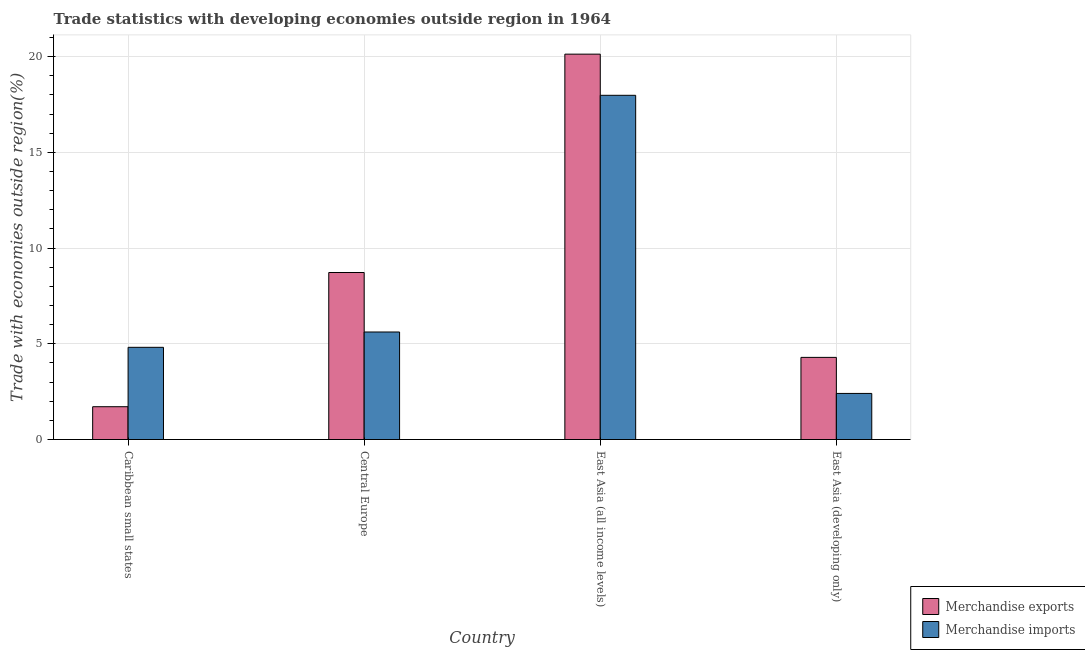How many different coloured bars are there?
Offer a very short reply. 2. How many groups of bars are there?
Your answer should be compact. 4. Are the number of bars per tick equal to the number of legend labels?
Ensure brevity in your answer.  Yes. Are the number of bars on each tick of the X-axis equal?
Provide a short and direct response. Yes. How many bars are there on the 4th tick from the right?
Make the answer very short. 2. What is the label of the 2nd group of bars from the left?
Give a very brief answer. Central Europe. In how many cases, is the number of bars for a given country not equal to the number of legend labels?
Your answer should be very brief. 0. What is the merchandise imports in East Asia (developing only)?
Offer a very short reply. 2.41. Across all countries, what is the maximum merchandise imports?
Your answer should be very brief. 17.98. Across all countries, what is the minimum merchandise imports?
Offer a terse response. 2.41. In which country was the merchandise imports maximum?
Your answer should be very brief. East Asia (all income levels). In which country was the merchandise exports minimum?
Provide a short and direct response. Caribbean small states. What is the total merchandise exports in the graph?
Give a very brief answer. 34.86. What is the difference between the merchandise imports in Caribbean small states and that in East Asia (all income levels)?
Give a very brief answer. -13.17. What is the difference between the merchandise exports in East Asia (developing only) and the merchandise imports in East Asia (all income levels)?
Give a very brief answer. -13.69. What is the average merchandise imports per country?
Give a very brief answer. 7.71. What is the difference between the merchandise imports and merchandise exports in East Asia (all income levels)?
Ensure brevity in your answer.  -2.15. What is the ratio of the merchandise exports in Caribbean small states to that in East Asia (all income levels)?
Your answer should be very brief. 0.09. Is the merchandise exports in Caribbean small states less than that in Central Europe?
Make the answer very short. Yes. What is the difference between the highest and the second highest merchandise imports?
Your response must be concise. 12.37. What is the difference between the highest and the lowest merchandise exports?
Ensure brevity in your answer.  18.42. How many bars are there?
Your answer should be very brief. 8. Are all the bars in the graph horizontal?
Make the answer very short. No. How many countries are there in the graph?
Provide a succinct answer. 4. Are the values on the major ticks of Y-axis written in scientific E-notation?
Make the answer very short. No. How many legend labels are there?
Keep it short and to the point. 2. What is the title of the graph?
Your response must be concise. Trade statistics with developing economies outside region in 1964. What is the label or title of the Y-axis?
Make the answer very short. Trade with economies outside region(%). What is the Trade with economies outside region(%) of Merchandise exports in Caribbean small states?
Your answer should be compact. 1.71. What is the Trade with economies outside region(%) in Merchandise imports in Caribbean small states?
Provide a short and direct response. 4.82. What is the Trade with economies outside region(%) of Merchandise exports in Central Europe?
Provide a short and direct response. 8.73. What is the Trade with economies outside region(%) of Merchandise imports in Central Europe?
Your answer should be very brief. 5.62. What is the Trade with economies outside region(%) in Merchandise exports in East Asia (all income levels)?
Your answer should be compact. 20.13. What is the Trade with economies outside region(%) in Merchandise imports in East Asia (all income levels)?
Your response must be concise. 17.98. What is the Trade with economies outside region(%) in Merchandise exports in East Asia (developing only)?
Provide a short and direct response. 4.29. What is the Trade with economies outside region(%) of Merchandise imports in East Asia (developing only)?
Your response must be concise. 2.41. Across all countries, what is the maximum Trade with economies outside region(%) in Merchandise exports?
Keep it short and to the point. 20.13. Across all countries, what is the maximum Trade with economies outside region(%) of Merchandise imports?
Provide a short and direct response. 17.98. Across all countries, what is the minimum Trade with economies outside region(%) in Merchandise exports?
Give a very brief answer. 1.71. Across all countries, what is the minimum Trade with economies outside region(%) in Merchandise imports?
Ensure brevity in your answer.  2.41. What is the total Trade with economies outside region(%) of Merchandise exports in the graph?
Your answer should be very brief. 34.86. What is the total Trade with economies outside region(%) in Merchandise imports in the graph?
Provide a succinct answer. 30.83. What is the difference between the Trade with economies outside region(%) of Merchandise exports in Caribbean small states and that in Central Europe?
Make the answer very short. -7.01. What is the difference between the Trade with economies outside region(%) in Merchandise imports in Caribbean small states and that in Central Europe?
Ensure brevity in your answer.  -0.8. What is the difference between the Trade with economies outside region(%) in Merchandise exports in Caribbean small states and that in East Asia (all income levels)?
Offer a very short reply. -18.42. What is the difference between the Trade with economies outside region(%) of Merchandise imports in Caribbean small states and that in East Asia (all income levels)?
Offer a terse response. -13.17. What is the difference between the Trade with economies outside region(%) of Merchandise exports in Caribbean small states and that in East Asia (developing only)?
Provide a succinct answer. -2.58. What is the difference between the Trade with economies outside region(%) of Merchandise imports in Caribbean small states and that in East Asia (developing only)?
Ensure brevity in your answer.  2.41. What is the difference between the Trade with economies outside region(%) in Merchandise exports in Central Europe and that in East Asia (all income levels)?
Make the answer very short. -11.41. What is the difference between the Trade with economies outside region(%) of Merchandise imports in Central Europe and that in East Asia (all income levels)?
Provide a short and direct response. -12.37. What is the difference between the Trade with economies outside region(%) of Merchandise exports in Central Europe and that in East Asia (developing only)?
Your response must be concise. 4.43. What is the difference between the Trade with economies outside region(%) in Merchandise imports in Central Europe and that in East Asia (developing only)?
Make the answer very short. 3.21. What is the difference between the Trade with economies outside region(%) of Merchandise exports in East Asia (all income levels) and that in East Asia (developing only)?
Ensure brevity in your answer.  15.84. What is the difference between the Trade with economies outside region(%) in Merchandise imports in East Asia (all income levels) and that in East Asia (developing only)?
Provide a succinct answer. 15.58. What is the difference between the Trade with economies outside region(%) in Merchandise exports in Caribbean small states and the Trade with economies outside region(%) in Merchandise imports in Central Europe?
Ensure brevity in your answer.  -3.9. What is the difference between the Trade with economies outside region(%) of Merchandise exports in Caribbean small states and the Trade with economies outside region(%) of Merchandise imports in East Asia (all income levels)?
Offer a terse response. -16.27. What is the difference between the Trade with economies outside region(%) in Merchandise exports in Caribbean small states and the Trade with economies outside region(%) in Merchandise imports in East Asia (developing only)?
Make the answer very short. -0.69. What is the difference between the Trade with economies outside region(%) of Merchandise exports in Central Europe and the Trade with economies outside region(%) of Merchandise imports in East Asia (all income levels)?
Offer a terse response. -9.26. What is the difference between the Trade with economies outside region(%) of Merchandise exports in Central Europe and the Trade with economies outside region(%) of Merchandise imports in East Asia (developing only)?
Provide a succinct answer. 6.32. What is the difference between the Trade with economies outside region(%) in Merchandise exports in East Asia (all income levels) and the Trade with economies outside region(%) in Merchandise imports in East Asia (developing only)?
Provide a short and direct response. 17.73. What is the average Trade with economies outside region(%) of Merchandise exports per country?
Provide a short and direct response. 8.72. What is the average Trade with economies outside region(%) of Merchandise imports per country?
Provide a succinct answer. 7.71. What is the difference between the Trade with economies outside region(%) in Merchandise exports and Trade with economies outside region(%) in Merchandise imports in Caribbean small states?
Keep it short and to the point. -3.1. What is the difference between the Trade with economies outside region(%) in Merchandise exports and Trade with economies outside region(%) in Merchandise imports in Central Europe?
Keep it short and to the point. 3.11. What is the difference between the Trade with economies outside region(%) of Merchandise exports and Trade with economies outside region(%) of Merchandise imports in East Asia (all income levels)?
Give a very brief answer. 2.15. What is the difference between the Trade with economies outside region(%) in Merchandise exports and Trade with economies outside region(%) in Merchandise imports in East Asia (developing only)?
Provide a short and direct response. 1.88. What is the ratio of the Trade with economies outside region(%) of Merchandise exports in Caribbean small states to that in Central Europe?
Your response must be concise. 0.2. What is the ratio of the Trade with economies outside region(%) of Merchandise imports in Caribbean small states to that in Central Europe?
Provide a short and direct response. 0.86. What is the ratio of the Trade with economies outside region(%) of Merchandise exports in Caribbean small states to that in East Asia (all income levels)?
Your answer should be very brief. 0.09. What is the ratio of the Trade with economies outside region(%) of Merchandise imports in Caribbean small states to that in East Asia (all income levels)?
Provide a short and direct response. 0.27. What is the ratio of the Trade with economies outside region(%) of Merchandise exports in Caribbean small states to that in East Asia (developing only)?
Give a very brief answer. 0.4. What is the ratio of the Trade with economies outside region(%) of Merchandise imports in Caribbean small states to that in East Asia (developing only)?
Offer a very short reply. 2. What is the ratio of the Trade with economies outside region(%) in Merchandise exports in Central Europe to that in East Asia (all income levels)?
Offer a very short reply. 0.43. What is the ratio of the Trade with economies outside region(%) of Merchandise imports in Central Europe to that in East Asia (all income levels)?
Make the answer very short. 0.31. What is the ratio of the Trade with economies outside region(%) of Merchandise exports in Central Europe to that in East Asia (developing only)?
Offer a terse response. 2.03. What is the ratio of the Trade with economies outside region(%) in Merchandise imports in Central Europe to that in East Asia (developing only)?
Your answer should be compact. 2.33. What is the ratio of the Trade with economies outside region(%) of Merchandise exports in East Asia (all income levels) to that in East Asia (developing only)?
Your answer should be very brief. 4.69. What is the ratio of the Trade with economies outside region(%) of Merchandise imports in East Asia (all income levels) to that in East Asia (developing only)?
Provide a short and direct response. 7.47. What is the difference between the highest and the second highest Trade with economies outside region(%) of Merchandise exports?
Your answer should be compact. 11.41. What is the difference between the highest and the second highest Trade with economies outside region(%) in Merchandise imports?
Offer a terse response. 12.37. What is the difference between the highest and the lowest Trade with economies outside region(%) of Merchandise exports?
Your answer should be compact. 18.42. What is the difference between the highest and the lowest Trade with economies outside region(%) of Merchandise imports?
Keep it short and to the point. 15.58. 